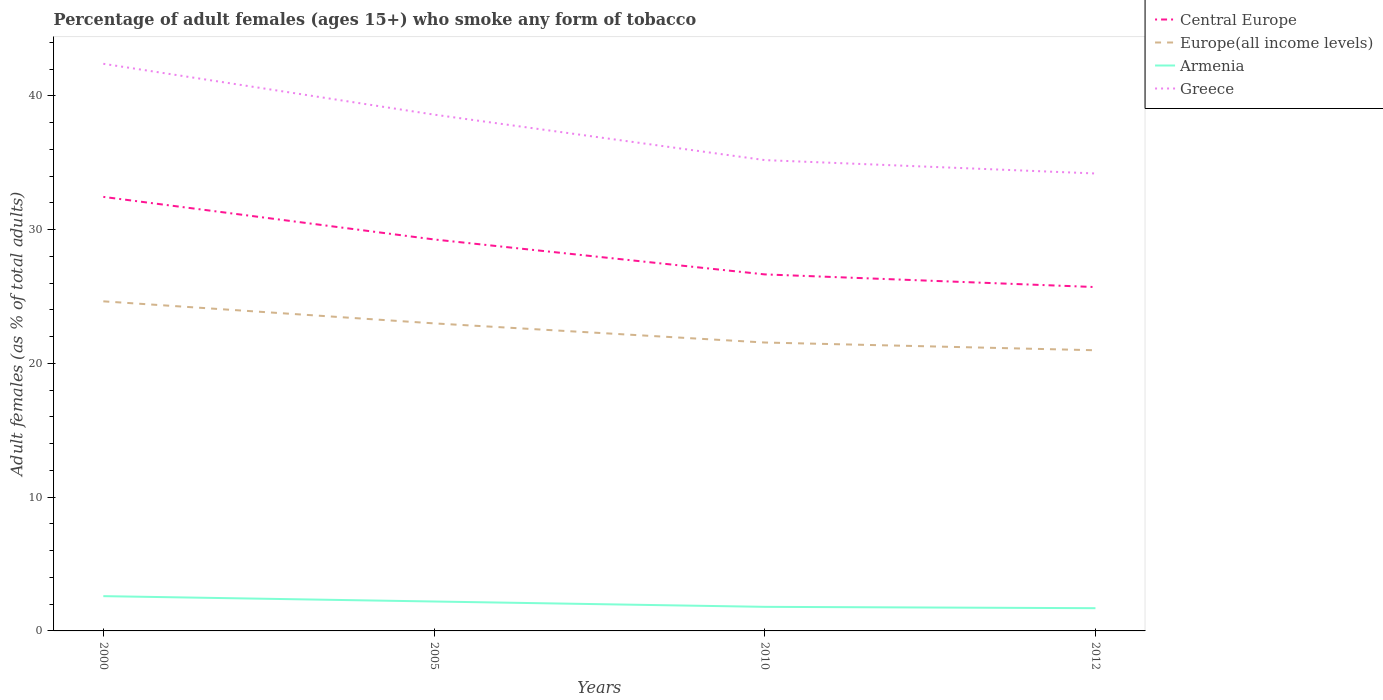How many different coloured lines are there?
Make the answer very short. 4. Does the line corresponding to Central Europe intersect with the line corresponding to Europe(all income levels)?
Your response must be concise. No. Across all years, what is the maximum percentage of adult females who smoke in Europe(all income levels)?
Provide a short and direct response. 20.98. In which year was the percentage of adult females who smoke in Armenia maximum?
Your answer should be compact. 2012. What is the total percentage of adult females who smoke in Greece in the graph?
Offer a very short reply. 8.2. What is the difference between the highest and the second highest percentage of adult females who smoke in Armenia?
Your answer should be very brief. 0.9. What is the difference between the highest and the lowest percentage of adult females who smoke in Europe(all income levels)?
Provide a short and direct response. 2. How many years are there in the graph?
Keep it short and to the point. 4. Are the values on the major ticks of Y-axis written in scientific E-notation?
Your response must be concise. No. Where does the legend appear in the graph?
Your response must be concise. Top right. How many legend labels are there?
Your answer should be compact. 4. How are the legend labels stacked?
Give a very brief answer. Vertical. What is the title of the graph?
Offer a very short reply. Percentage of adult females (ages 15+) who smoke any form of tobacco. Does "Caribbean small states" appear as one of the legend labels in the graph?
Offer a very short reply. No. What is the label or title of the Y-axis?
Give a very brief answer. Adult females (as % of total adults). What is the Adult females (as % of total adults) in Central Europe in 2000?
Give a very brief answer. 32.45. What is the Adult females (as % of total adults) in Europe(all income levels) in 2000?
Your answer should be very brief. 24.64. What is the Adult females (as % of total adults) in Armenia in 2000?
Offer a terse response. 2.6. What is the Adult females (as % of total adults) of Greece in 2000?
Offer a very short reply. 42.4. What is the Adult females (as % of total adults) in Central Europe in 2005?
Your answer should be very brief. 29.27. What is the Adult females (as % of total adults) in Europe(all income levels) in 2005?
Provide a short and direct response. 22.99. What is the Adult females (as % of total adults) of Greece in 2005?
Your answer should be compact. 38.6. What is the Adult females (as % of total adults) in Central Europe in 2010?
Provide a succinct answer. 26.65. What is the Adult females (as % of total adults) of Europe(all income levels) in 2010?
Your answer should be very brief. 21.56. What is the Adult females (as % of total adults) in Armenia in 2010?
Your answer should be compact. 1.8. What is the Adult females (as % of total adults) in Greece in 2010?
Make the answer very short. 35.2. What is the Adult females (as % of total adults) of Central Europe in 2012?
Give a very brief answer. 25.71. What is the Adult females (as % of total adults) in Europe(all income levels) in 2012?
Your response must be concise. 20.98. What is the Adult females (as % of total adults) in Armenia in 2012?
Provide a succinct answer. 1.7. What is the Adult females (as % of total adults) of Greece in 2012?
Offer a very short reply. 34.2. Across all years, what is the maximum Adult females (as % of total adults) in Central Europe?
Your response must be concise. 32.45. Across all years, what is the maximum Adult females (as % of total adults) of Europe(all income levels)?
Your answer should be compact. 24.64. Across all years, what is the maximum Adult females (as % of total adults) of Armenia?
Your answer should be compact. 2.6. Across all years, what is the maximum Adult females (as % of total adults) in Greece?
Make the answer very short. 42.4. Across all years, what is the minimum Adult females (as % of total adults) in Central Europe?
Offer a terse response. 25.71. Across all years, what is the minimum Adult females (as % of total adults) of Europe(all income levels)?
Offer a terse response. 20.98. Across all years, what is the minimum Adult females (as % of total adults) in Armenia?
Offer a terse response. 1.7. Across all years, what is the minimum Adult females (as % of total adults) in Greece?
Give a very brief answer. 34.2. What is the total Adult females (as % of total adults) in Central Europe in the graph?
Your answer should be compact. 114.08. What is the total Adult females (as % of total adults) in Europe(all income levels) in the graph?
Keep it short and to the point. 90.18. What is the total Adult females (as % of total adults) of Armenia in the graph?
Your response must be concise. 8.3. What is the total Adult females (as % of total adults) in Greece in the graph?
Make the answer very short. 150.4. What is the difference between the Adult females (as % of total adults) in Central Europe in 2000 and that in 2005?
Provide a short and direct response. 3.18. What is the difference between the Adult females (as % of total adults) of Europe(all income levels) in 2000 and that in 2005?
Offer a terse response. 1.65. What is the difference between the Adult females (as % of total adults) of Armenia in 2000 and that in 2005?
Ensure brevity in your answer.  0.4. What is the difference between the Adult females (as % of total adults) of Greece in 2000 and that in 2005?
Your response must be concise. 3.8. What is the difference between the Adult females (as % of total adults) in Central Europe in 2000 and that in 2010?
Your answer should be compact. 5.8. What is the difference between the Adult females (as % of total adults) of Europe(all income levels) in 2000 and that in 2010?
Provide a succinct answer. 3.08. What is the difference between the Adult females (as % of total adults) in Armenia in 2000 and that in 2010?
Offer a terse response. 0.8. What is the difference between the Adult females (as % of total adults) in Greece in 2000 and that in 2010?
Your answer should be compact. 7.2. What is the difference between the Adult females (as % of total adults) in Central Europe in 2000 and that in 2012?
Offer a very short reply. 6.74. What is the difference between the Adult females (as % of total adults) of Europe(all income levels) in 2000 and that in 2012?
Offer a very short reply. 3.66. What is the difference between the Adult females (as % of total adults) of Central Europe in 2005 and that in 2010?
Give a very brief answer. 2.61. What is the difference between the Adult females (as % of total adults) in Europe(all income levels) in 2005 and that in 2010?
Give a very brief answer. 1.43. What is the difference between the Adult females (as % of total adults) in Central Europe in 2005 and that in 2012?
Your answer should be very brief. 3.56. What is the difference between the Adult females (as % of total adults) in Europe(all income levels) in 2005 and that in 2012?
Make the answer very short. 2.01. What is the difference between the Adult females (as % of total adults) of Armenia in 2005 and that in 2012?
Make the answer very short. 0.5. What is the difference between the Adult females (as % of total adults) in Central Europe in 2010 and that in 2012?
Ensure brevity in your answer.  0.95. What is the difference between the Adult females (as % of total adults) in Europe(all income levels) in 2010 and that in 2012?
Keep it short and to the point. 0.58. What is the difference between the Adult females (as % of total adults) of Armenia in 2010 and that in 2012?
Keep it short and to the point. 0.1. What is the difference between the Adult females (as % of total adults) in Greece in 2010 and that in 2012?
Keep it short and to the point. 1. What is the difference between the Adult females (as % of total adults) of Central Europe in 2000 and the Adult females (as % of total adults) of Europe(all income levels) in 2005?
Provide a short and direct response. 9.46. What is the difference between the Adult females (as % of total adults) in Central Europe in 2000 and the Adult females (as % of total adults) in Armenia in 2005?
Your answer should be very brief. 30.25. What is the difference between the Adult females (as % of total adults) of Central Europe in 2000 and the Adult females (as % of total adults) of Greece in 2005?
Ensure brevity in your answer.  -6.15. What is the difference between the Adult females (as % of total adults) of Europe(all income levels) in 2000 and the Adult females (as % of total adults) of Armenia in 2005?
Make the answer very short. 22.44. What is the difference between the Adult females (as % of total adults) in Europe(all income levels) in 2000 and the Adult females (as % of total adults) in Greece in 2005?
Your answer should be very brief. -13.96. What is the difference between the Adult females (as % of total adults) of Armenia in 2000 and the Adult females (as % of total adults) of Greece in 2005?
Provide a short and direct response. -36. What is the difference between the Adult females (as % of total adults) of Central Europe in 2000 and the Adult females (as % of total adults) of Europe(all income levels) in 2010?
Provide a succinct answer. 10.89. What is the difference between the Adult females (as % of total adults) in Central Europe in 2000 and the Adult females (as % of total adults) in Armenia in 2010?
Give a very brief answer. 30.65. What is the difference between the Adult females (as % of total adults) in Central Europe in 2000 and the Adult females (as % of total adults) in Greece in 2010?
Give a very brief answer. -2.75. What is the difference between the Adult females (as % of total adults) in Europe(all income levels) in 2000 and the Adult females (as % of total adults) in Armenia in 2010?
Provide a succinct answer. 22.84. What is the difference between the Adult females (as % of total adults) of Europe(all income levels) in 2000 and the Adult females (as % of total adults) of Greece in 2010?
Provide a succinct answer. -10.56. What is the difference between the Adult females (as % of total adults) in Armenia in 2000 and the Adult females (as % of total adults) in Greece in 2010?
Offer a terse response. -32.6. What is the difference between the Adult females (as % of total adults) in Central Europe in 2000 and the Adult females (as % of total adults) in Europe(all income levels) in 2012?
Your answer should be very brief. 11.47. What is the difference between the Adult females (as % of total adults) in Central Europe in 2000 and the Adult females (as % of total adults) in Armenia in 2012?
Offer a terse response. 30.75. What is the difference between the Adult females (as % of total adults) of Central Europe in 2000 and the Adult females (as % of total adults) of Greece in 2012?
Provide a succinct answer. -1.75. What is the difference between the Adult females (as % of total adults) in Europe(all income levels) in 2000 and the Adult females (as % of total adults) in Armenia in 2012?
Your answer should be compact. 22.94. What is the difference between the Adult females (as % of total adults) in Europe(all income levels) in 2000 and the Adult females (as % of total adults) in Greece in 2012?
Make the answer very short. -9.56. What is the difference between the Adult females (as % of total adults) in Armenia in 2000 and the Adult females (as % of total adults) in Greece in 2012?
Provide a short and direct response. -31.6. What is the difference between the Adult females (as % of total adults) of Central Europe in 2005 and the Adult females (as % of total adults) of Europe(all income levels) in 2010?
Your answer should be compact. 7.71. What is the difference between the Adult females (as % of total adults) in Central Europe in 2005 and the Adult females (as % of total adults) in Armenia in 2010?
Keep it short and to the point. 27.47. What is the difference between the Adult females (as % of total adults) of Central Europe in 2005 and the Adult females (as % of total adults) of Greece in 2010?
Make the answer very short. -5.93. What is the difference between the Adult females (as % of total adults) of Europe(all income levels) in 2005 and the Adult females (as % of total adults) of Armenia in 2010?
Give a very brief answer. 21.19. What is the difference between the Adult females (as % of total adults) in Europe(all income levels) in 2005 and the Adult females (as % of total adults) in Greece in 2010?
Provide a succinct answer. -12.21. What is the difference between the Adult females (as % of total adults) of Armenia in 2005 and the Adult females (as % of total adults) of Greece in 2010?
Offer a terse response. -33. What is the difference between the Adult females (as % of total adults) in Central Europe in 2005 and the Adult females (as % of total adults) in Europe(all income levels) in 2012?
Your response must be concise. 8.28. What is the difference between the Adult females (as % of total adults) in Central Europe in 2005 and the Adult females (as % of total adults) in Armenia in 2012?
Ensure brevity in your answer.  27.57. What is the difference between the Adult females (as % of total adults) in Central Europe in 2005 and the Adult females (as % of total adults) in Greece in 2012?
Ensure brevity in your answer.  -4.93. What is the difference between the Adult females (as % of total adults) of Europe(all income levels) in 2005 and the Adult females (as % of total adults) of Armenia in 2012?
Ensure brevity in your answer.  21.29. What is the difference between the Adult females (as % of total adults) of Europe(all income levels) in 2005 and the Adult females (as % of total adults) of Greece in 2012?
Your answer should be very brief. -11.21. What is the difference between the Adult females (as % of total adults) in Armenia in 2005 and the Adult females (as % of total adults) in Greece in 2012?
Keep it short and to the point. -32. What is the difference between the Adult females (as % of total adults) of Central Europe in 2010 and the Adult females (as % of total adults) of Europe(all income levels) in 2012?
Your answer should be very brief. 5.67. What is the difference between the Adult females (as % of total adults) of Central Europe in 2010 and the Adult females (as % of total adults) of Armenia in 2012?
Keep it short and to the point. 24.95. What is the difference between the Adult females (as % of total adults) of Central Europe in 2010 and the Adult females (as % of total adults) of Greece in 2012?
Your response must be concise. -7.54. What is the difference between the Adult females (as % of total adults) in Europe(all income levels) in 2010 and the Adult females (as % of total adults) in Armenia in 2012?
Offer a very short reply. 19.86. What is the difference between the Adult females (as % of total adults) of Europe(all income levels) in 2010 and the Adult females (as % of total adults) of Greece in 2012?
Give a very brief answer. -12.64. What is the difference between the Adult females (as % of total adults) of Armenia in 2010 and the Adult females (as % of total adults) of Greece in 2012?
Your answer should be compact. -32.4. What is the average Adult females (as % of total adults) in Central Europe per year?
Ensure brevity in your answer.  28.52. What is the average Adult females (as % of total adults) of Europe(all income levels) per year?
Your response must be concise. 22.55. What is the average Adult females (as % of total adults) in Armenia per year?
Make the answer very short. 2.08. What is the average Adult females (as % of total adults) in Greece per year?
Your answer should be compact. 37.6. In the year 2000, what is the difference between the Adult females (as % of total adults) of Central Europe and Adult females (as % of total adults) of Europe(all income levels)?
Offer a very short reply. 7.81. In the year 2000, what is the difference between the Adult females (as % of total adults) of Central Europe and Adult females (as % of total adults) of Armenia?
Offer a terse response. 29.85. In the year 2000, what is the difference between the Adult females (as % of total adults) in Central Europe and Adult females (as % of total adults) in Greece?
Your answer should be compact. -9.95. In the year 2000, what is the difference between the Adult females (as % of total adults) of Europe(all income levels) and Adult females (as % of total adults) of Armenia?
Ensure brevity in your answer.  22.04. In the year 2000, what is the difference between the Adult females (as % of total adults) in Europe(all income levels) and Adult females (as % of total adults) in Greece?
Offer a very short reply. -17.76. In the year 2000, what is the difference between the Adult females (as % of total adults) of Armenia and Adult females (as % of total adults) of Greece?
Your response must be concise. -39.8. In the year 2005, what is the difference between the Adult females (as % of total adults) of Central Europe and Adult females (as % of total adults) of Europe(all income levels)?
Provide a short and direct response. 6.27. In the year 2005, what is the difference between the Adult females (as % of total adults) in Central Europe and Adult females (as % of total adults) in Armenia?
Provide a succinct answer. 27.07. In the year 2005, what is the difference between the Adult females (as % of total adults) in Central Europe and Adult females (as % of total adults) in Greece?
Offer a very short reply. -9.33. In the year 2005, what is the difference between the Adult females (as % of total adults) of Europe(all income levels) and Adult females (as % of total adults) of Armenia?
Ensure brevity in your answer.  20.79. In the year 2005, what is the difference between the Adult females (as % of total adults) of Europe(all income levels) and Adult females (as % of total adults) of Greece?
Make the answer very short. -15.61. In the year 2005, what is the difference between the Adult females (as % of total adults) in Armenia and Adult females (as % of total adults) in Greece?
Ensure brevity in your answer.  -36.4. In the year 2010, what is the difference between the Adult females (as % of total adults) in Central Europe and Adult females (as % of total adults) in Europe(all income levels)?
Provide a short and direct response. 5.09. In the year 2010, what is the difference between the Adult females (as % of total adults) in Central Europe and Adult females (as % of total adults) in Armenia?
Provide a succinct answer. 24.86. In the year 2010, what is the difference between the Adult females (as % of total adults) in Central Europe and Adult females (as % of total adults) in Greece?
Ensure brevity in your answer.  -8.54. In the year 2010, what is the difference between the Adult females (as % of total adults) of Europe(all income levels) and Adult females (as % of total adults) of Armenia?
Provide a succinct answer. 19.76. In the year 2010, what is the difference between the Adult females (as % of total adults) of Europe(all income levels) and Adult females (as % of total adults) of Greece?
Provide a succinct answer. -13.64. In the year 2010, what is the difference between the Adult females (as % of total adults) of Armenia and Adult females (as % of total adults) of Greece?
Provide a succinct answer. -33.4. In the year 2012, what is the difference between the Adult females (as % of total adults) in Central Europe and Adult females (as % of total adults) in Europe(all income levels)?
Give a very brief answer. 4.72. In the year 2012, what is the difference between the Adult females (as % of total adults) in Central Europe and Adult females (as % of total adults) in Armenia?
Your answer should be very brief. 24.01. In the year 2012, what is the difference between the Adult females (as % of total adults) of Central Europe and Adult females (as % of total adults) of Greece?
Provide a succinct answer. -8.49. In the year 2012, what is the difference between the Adult females (as % of total adults) in Europe(all income levels) and Adult females (as % of total adults) in Armenia?
Your response must be concise. 19.28. In the year 2012, what is the difference between the Adult females (as % of total adults) of Europe(all income levels) and Adult females (as % of total adults) of Greece?
Offer a terse response. -13.22. In the year 2012, what is the difference between the Adult females (as % of total adults) in Armenia and Adult females (as % of total adults) in Greece?
Keep it short and to the point. -32.5. What is the ratio of the Adult females (as % of total adults) of Central Europe in 2000 to that in 2005?
Your answer should be very brief. 1.11. What is the ratio of the Adult females (as % of total adults) of Europe(all income levels) in 2000 to that in 2005?
Provide a succinct answer. 1.07. What is the ratio of the Adult females (as % of total adults) of Armenia in 2000 to that in 2005?
Your answer should be very brief. 1.18. What is the ratio of the Adult females (as % of total adults) of Greece in 2000 to that in 2005?
Give a very brief answer. 1.1. What is the ratio of the Adult females (as % of total adults) of Central Europe in 2000 to that in 2010?
Your response must be concise. 1.22. What is the ratio of the Adult females (as % of total adults) in Europe(all income levels) in 2000 to that in 2010?
Your response must be concise. 1.14. What is the ratio of the Adult females (as % of total adults) of Armenia in 2000 to that in 2010?
Provide a succinct answer. 1.44. What is the ratio of the Adult females (as % of total adults) of Greece in 2000 to that in 2010?
Your response must be concise. 1.2. What is the ratio of the Adult females (as % of total adults) in Central Europe in 2000 to that in 2012?
Offer a terse response. 1.26. What is the ratio of the Adult females (as % of total adults) of Europe(all income levels) in 2000 to that in 2012?
Your answer should be very brief. 1.17. What is the ratio of the Adult females (as % of total adults) of Armenia in 2000 to that in 2012?
Your answer should be compact. 1.53. What is the ratio of the Adult females (as % of total adults) in Greece in 2000 to that in 2012?
Ensure brevity in your answer.  1.24. What is the ratio of the Adult females (as % of total adults) of Central Europe in 2005 to that in 2010?
Make the answer very short. 1.1. What is the ratio of the Adult females (as % of total adults) in Europe(all income levels) in 2005 to that in 2010?
Offer a terse response. 1.07. What is the ratio of the Adult females (as % of total adults) of Armenia in 2005 to that in 2010?
Provide a succinct answer. 1.22. What is the ratio of the Adult females (as % of total adults) of Greece in 2005 to that in 2010?
Give a very brief answer. 1.1. What is the ratio of the Adult females (as % of total adults) of Central Europe in 2005 to that in 2012?
Give a very brief answer. 1.14. What is the ratio of the Adult females (as % of total adults) in Europe(all income levels) in 2005 to that in 2012?
Keep it short and to the point. 1.1. What is the ratio of the Adult females (as % of total adults) of Armenia in 2005 to that in 2012?
Ensure brevity in your answer.  1.29. What is the ratio of the Adult females (as % of total adults) in Greece in 2005 to that in 2012?
Offer a very short reply. 1.13. What is the ratio of the Adult females (as % of total adults) of Central Europe in 2010 to that in 2012?
Give a very brief answer. 1.04. What is the ratio of the Adult females (as % of total adults) of Europe(all income levels) in 2010 to that in 2012?
Your answer should be compact. 1.03. What is the ratio of the Adult females (as % of total adults) of Armenia in 2010 to that in 2012?
Give a very brief answer. 1.06. What is the ratio of the Adult females (as % of total adults) of Greece in 2010 to that in 2012?
Keep it short and to the point. 1.03. What is the difference between the highest and the second highest Adult females (as % of total adults) in Central Europe?
Your response must be concise. 3.18. What is the difference between the highest and the second highest Adult females (as % of total adults) in Europe(all income levels)?
Your response must be concise. 1.65. What is the difference between the highest and the second highest Adult females (as % of total adults) in Armenia?
Make the answer very short. 0.4. What is the difference between the highest and the second highest Adult females (as % of total adults) in Greece?
Give a very brief answer. 3.8. What is the difference between the highest and the lowest Adult females (as % of total adults) of Central Europe?
Your answer should be very brief. 6.74. What is the difference between the highest and the lowest Adult females (as % of total adults) of Europe(all income levels)?
Keep it short and to the point. 3.66. 